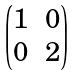Convert formula to latex. <formula><loc_0><loc_0><loc_500><loc_500>\begin{pmatrix} 1 & 0 \\ 0 & 2 \end{pmatrix}</formula> 